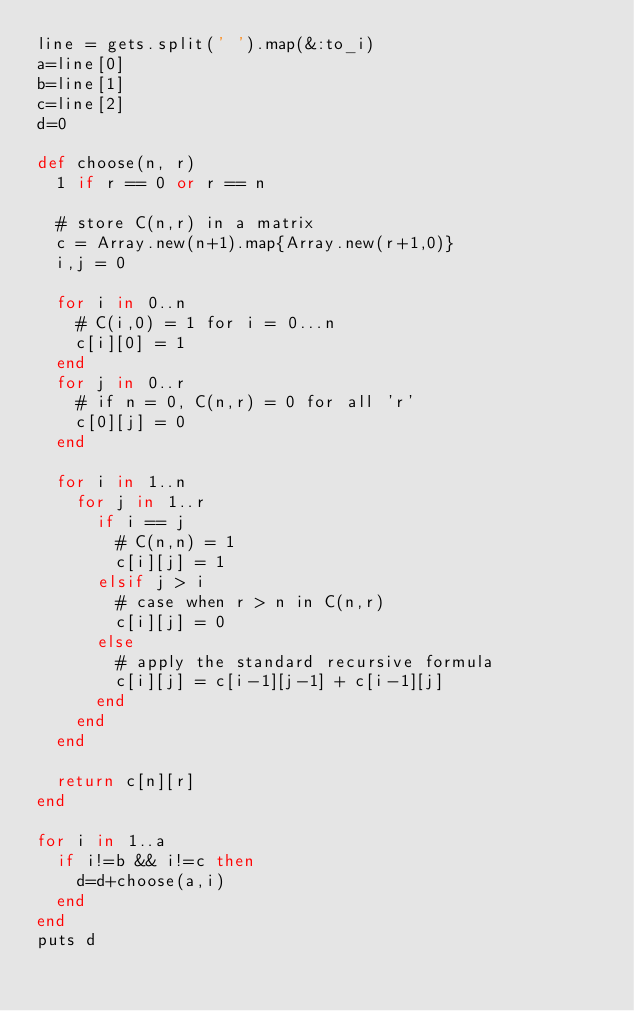<code> <loc_0><loc_0><loc_500><loc_500><_Ruby_>line = gets.split(' ').map(&:to_i)
a=line[0]
b=line[1]
c=line[2]
d=0

def choose(n, r)
  1 if r == 0 or r == n

  # store C(n,r) in a matrix
  c = Array.new(n+1).map{Array.new(r+1,0)}
  i,j = 0

  for i in 0..n
    # C(i,0) = 1 for i = 0...n
    c[i][0] = 1
  end
  for j in 0..r
    # if n = 0, C(n,r) = 0 for all 'r'
    c[0][j] = 0
  end

  for i in 1..n
    for j in 1..r
      if i == j
        # C(n,n) = 1
        c[i][j] = 1
      elsif j > i
        # case when r > n in C(n,r)
        c[i][j] = 0
      else
        # apply the standard recursive formula
        c[i][j] = c[i-1][j-1] + c[i-1][j]
      end
    end
  end

  return c[n][r]
end

for i in 1..a
  if i!=b && i!=c then
    d=d+choose(a,i)
  end
end
puts d</code> 